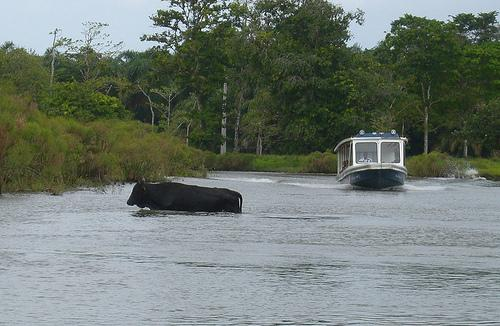Mention some specific objects from the scene, and their relative positions. A large black yak can be seen treading through water on the left side of the image, while the blue and white tourist boat is sailing to the right. Provide a brief overview of the scenery depicted in the image. The image presents a tranquil river and forest view, with a boat and a yak in the water, white clouds in the blue sky, and green leaves in the trees. Write a sentence about the interaction between the boat and the cow in the image. The boat and the yak are both navigating the calm river waters, creating a picturesque scene alongside the shore. Describe the boat navigating in the water. The boat is a silver and blue, driving through the water with people looking out the side and a man steering the vessel in front. Summarize this image in the style of a short poem or haiku. nature's beauty, pristine. What are the main elements of nature shown in the image? The main natural elements in the image are the river, forest, trees with green leaves, and the blue sky with white clouds. State the main focus of the photo and how it makes you feel. The river and forest scenery evoke a feeling of tranquility, with the boat and the yak adding a unique charm to the peaceful view. Explain what you see in the water in this picture. In the water, there is a black cow, a blue and white tourist boat, white waves, and a reflection of the cow. What is the overall atmosphere of the image? The atmosphere of the image is calm and serene, with the boat and cow in the river, surrounded by the beauty of nature. Write about the trees in the image using an artistic language style. Bushy trees of varied sizes grace the landscape, their thick foliage whispering tales of nature's resplendence in shades of green and brown. 